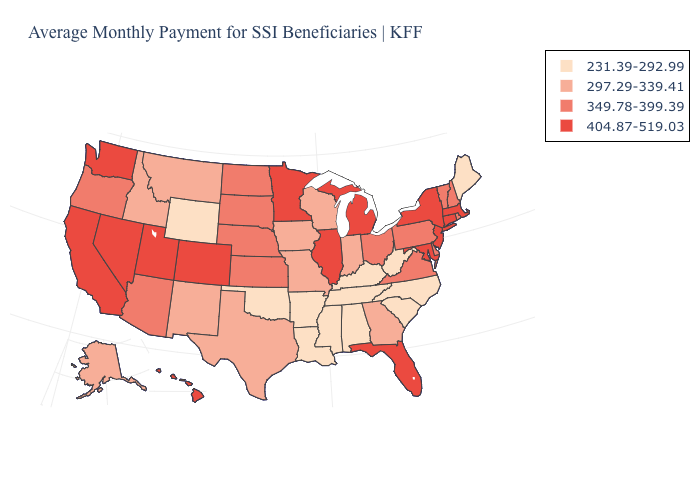Does Pennsylvania have the same value as Arizona?
Short answer required. Yes. What is the value of Maine?
Give a very brief answer. 231.39-292.99. What is the lowest value in states that border Colorado?
Short answer required. 231.39-292.99. Name the states that have a value in the range 349.78-399.39?
Keep it brief. Arizona, Delaware, Kansas, Nebraska, New Hampshire, North Dakota, Ohio, Oregon, Pennsylvania, Rhode Island, South Dakota, Vermont, Virginia. Does Indiana have the highest value in the MidWest?
Answer briefly. No. Does Rhode Island have a higher value than South Carolina?
Write a very short answer. Yes. What is the value of Georgia?
Write a very short answer. 297.29-339.41. What is the value of Hawaii?
Quick response, please. 404.87-519.03. Name the states that have a value in the range 231.39-292.99?
Quick response, please. Alabama, Arkansas, Kentucky, Louisiana, Maine, Mississippi, North Carolina, Oklahoma, South Carolina, Tennessee, West Virginia, Wyoming. Does Texas have a higher value than New Jersey?
Be succinct. No. Among the states that border Missouri , which have the highest value?
Short answer required. Illinois. Among the states that border Massachusetts , does New York have the highest value?
Short answer required. Yes. Does Alaska have the same value as Missouri?
Keep it brief. Yes. Name the states that have a value in the range 349.78-399.39?
Quick response, please. Arizona, Delaware, Kansas, Nebraska, New Hampshire, North Dakota, Ohio, Oregon, Pennsylvania, Rhode Island, South Dakota, Vermont, Virginia. Name the states that have a value in the range 349.78-399.39?
Concise answer only. Arizona, Delaware, Kansas, Nebraska, New Hampshire, North Dakota, Ohio, Oregon, Pennsylvania, Rhode Island, South Dakota, Vermont, Virginia. 